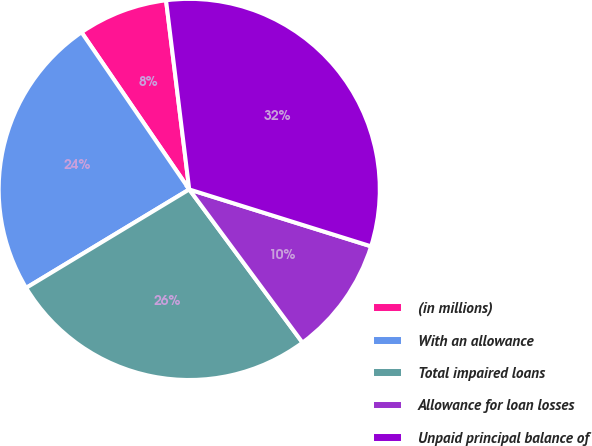Convert chart to OTSL. <chart><loc_0><loc_0><loc_500><loc_500><pie_chart><fcel>(in millions)<fcel>With an allowance<fcel>Total impaired loans<fcel>Allowance for loan losses<fcel>Unpaid principal balance of<nl><fcel>7.62%<fcel>24.08%<fcel>26.49%<fcel>10.04%<fcel>31.77%<nl></chart> 